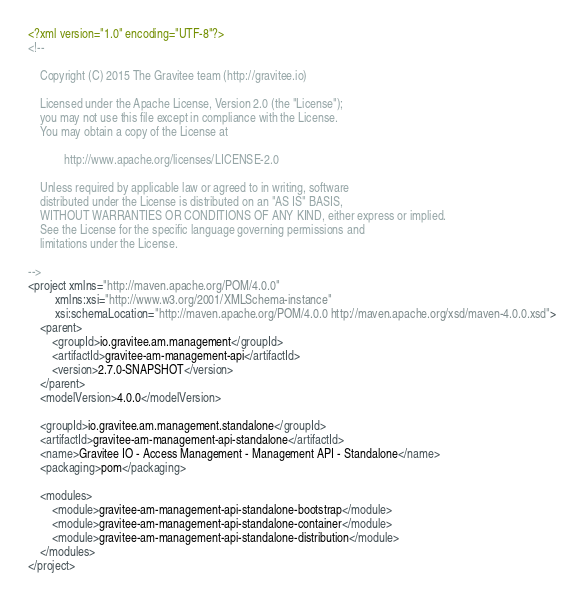<code> <loc_0><loc_0><loc_500><loc_500><_XML_><?xml version="1.0" encoding="UTF-8"?>
<!--

    Copyright (C) 2015 The Gravitee team (http://gravitee.io)

    Licensed under the Apache License, Version 2.0 (the "License");
    you may not use this file except in compliance with the License.
    You may obtain a copy of the License at

            http://www.apache.org/licenses/LICENSE-2.0

    Unless required by applicable law or agreed to in writing, software
    distributed under the License is distributed on an "AS IS" BASIS,
    WITHOUT WARRANTIES OR CONDITIONS OF ANY KIND, either express or implied.
    See the License for the specific language governing permissions and
    limitations under the License.

-->
<project xmlns="http://maven.apache.org/POM/4.0.0"
         xmlns:xsi="http://www.w3.org/2001/XMLSchema-instance"
         xsi:schemaLocation="http://maven.apache.org/POM/4.0.0 http://maven.apache.org/xsd/maven-4.0.0.xsd">
    <parent>
        <groupId>io.gravitee.am.management</groupId>
        <artifactId>gravitee-am-management-api</artifactId>
        <version>2.7.0-SNAPSHOT</version>
    </parent>
    <modelVersion>4.0.0</modelVersion>

    <groupId>io.gravitee.am.management.standalone</groupId>
    <artifactId>gravitee-am-management-api-standalone</artifactId>
    <name>Gravitee IO - Access Management - Management API - Standalone</name>
    <packaging>pom</packaging>

    <modules>
        <module>gravitee-am-management-api-standalone-bootstrap</module>
        <module>gravitee-am-management-api-standalone-container</module>
        <module>gravitee-am-management-api-standalone-distribution</module>
    </modules>
</project></code> 